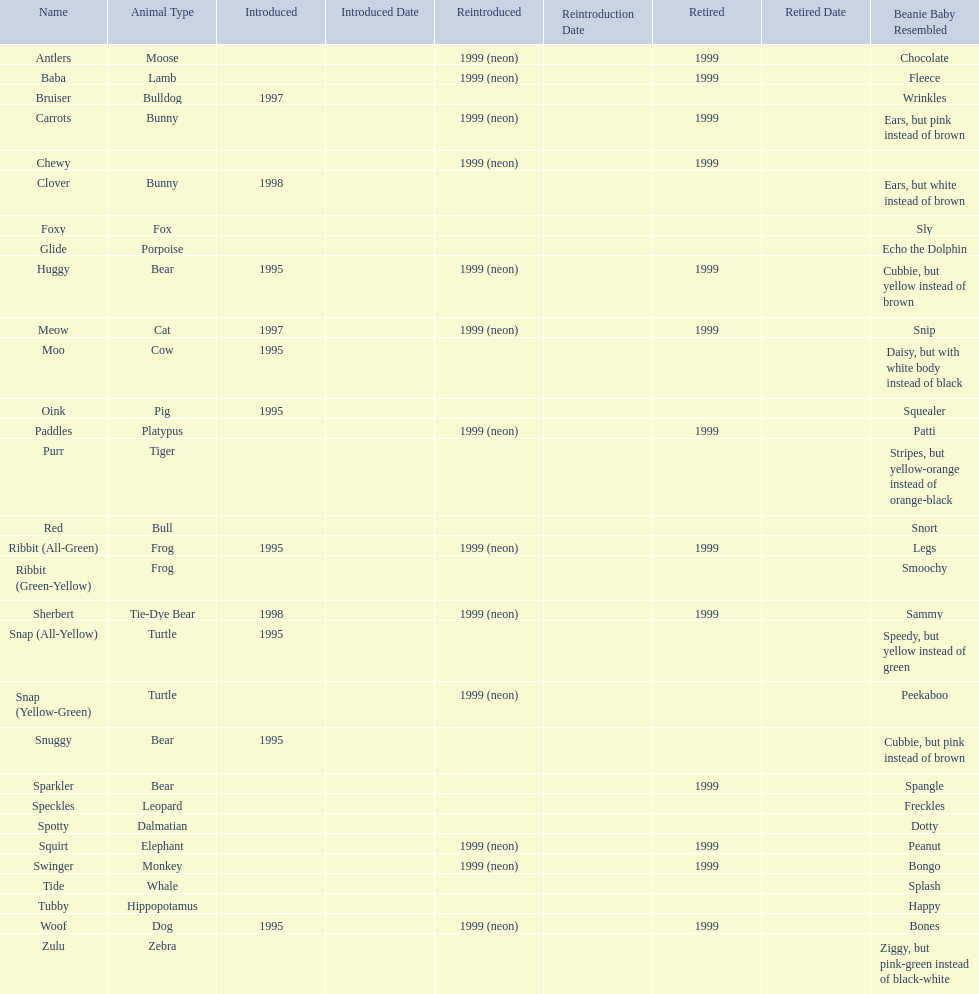Name the only pillow pal that is a dalmatian. Spotty. 